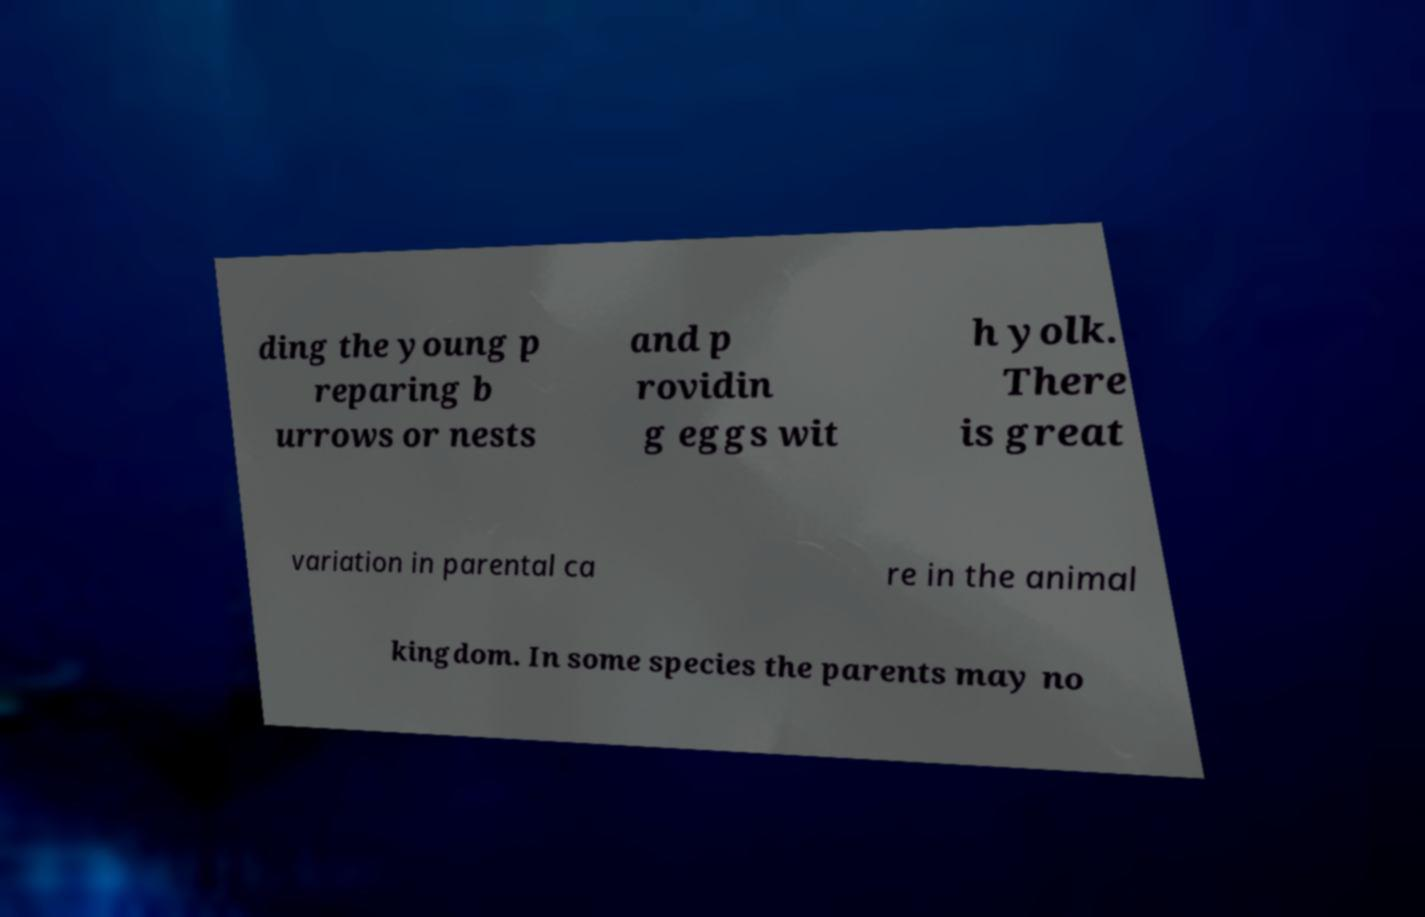There's text embedded in this image that I need extracted. Can you transcribe it verbatim? ding the young p reparing b urrows or nests and p rovidin g eggs wit h yolk. There is great variation in parental ca re in the animal kingdom. In some species the parents may no 